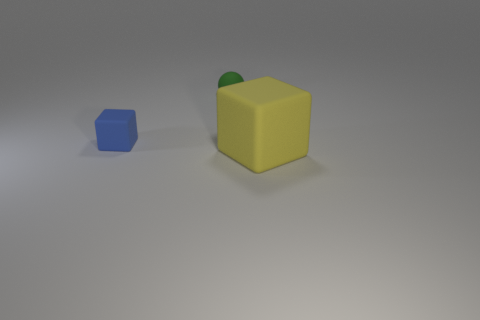Add 2 tiny purple spheres. How many objects exist? 5 Subtract all blue cubes. How many cubes are left? 1 Subtract all blocks. How many objects are left? 1 Subtract all purple blocks. Subtract all yellow balls. How many blocks are left? 2 Subtract all yellow cylinders. How many red spheres are left? 0 Subtract all large purple shiny balls. Subtract all yellow rubber objects. How many objects are left? 2 Add 2 small green matte balls. How many small green matte balls are left? 3 Add 3 blue things. How many blue things exist? 4 Subtract 0 purple cylinders. How many objects are left? 3 